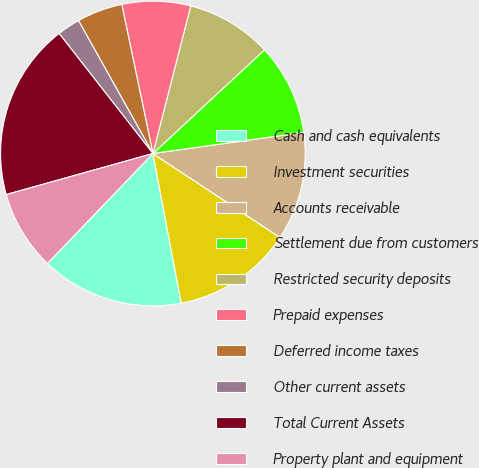Convert chart. <chart><loc_0><loc_0><loc_500><loc_500><pie_chart><fcel>Cash and cash equivalents<fcel>Investment securities<fcel>Accounts receivable<fcel>Settlement due from customers<fcel>Restricted security deposits<fcel>Prepaid expenses<fcel>Deferred income taxes<fcel>Other current assets<fcel>Total Current Assets<fcel>Property plant and equipment<nl><fcel>15.15%<fcel>12.73%<fcel>11.51%<fcel>9.7%<fcel>9.09%<fcel>7.27%<fcel>4.85%<fcel>2.43%<fcel>18.79%<fcel>8.49%<nl></chart> 